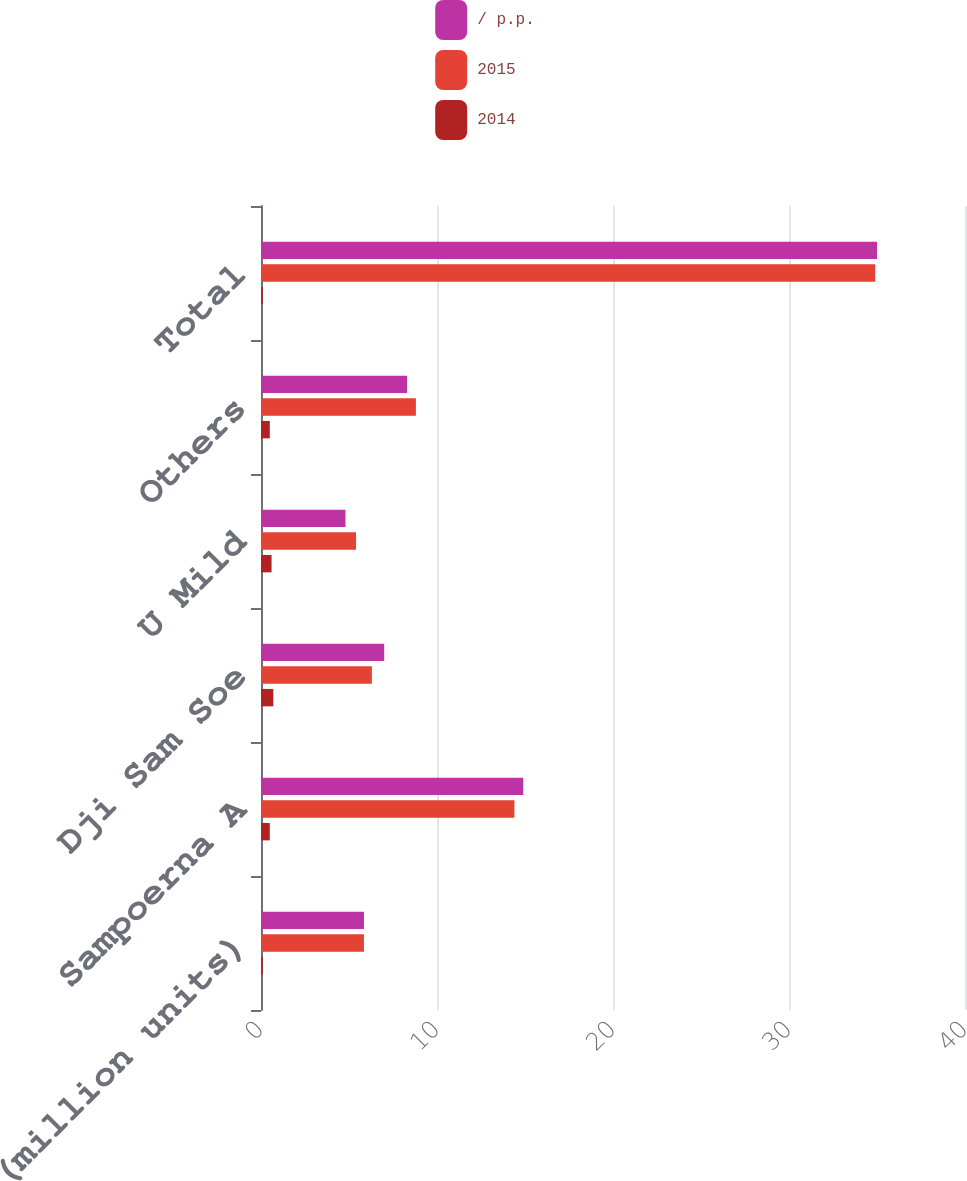Convert chart. <chart><loc_0><loc_0><loc_500><loc_500><stacked_bar_chart><ecel><fcel>PMI Shipments (million units)<fcel>Sampoerna A<fcel>Dji Sam Soe<fcel>U Mild<fcel>Others<fcel>Total<nl><fcel>/ p.p.<fcel>5.85<fcel>14.9<fcel>7<fcel>4.8<fcel>8.3<fcel>35<nl><fcel>2015<fcel>5.85<fcel>14.4<fcel>6.3<fcel>5.4<fcel>8.8<fcel>34.9<nl><fcel>2014<fcel>0.1<fcel>0.5<fcel>0.7<fcel>0.6<fcel>0.5<fcel>0.1<nl></chart> 